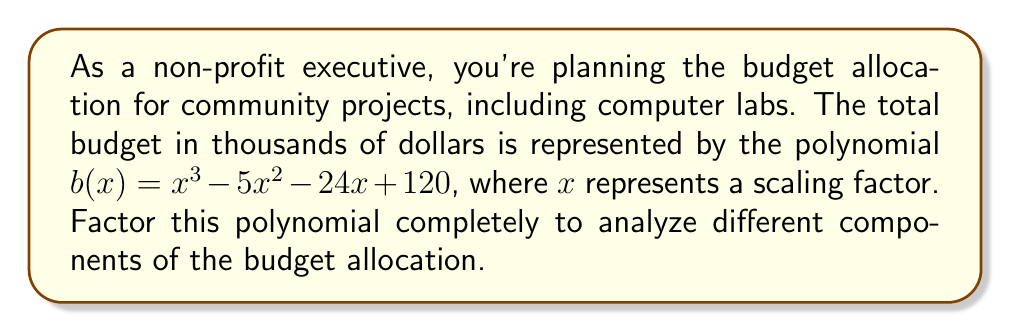Provide a solution to this math problem. To factor this polynomial, we'll follow these steps:

1) First, let's check if there are any common factors. In this case, there are none.

2) Next, we'll try to find a factor using the rational root theorem. The possible rational roots are the factors of the constant term (120): ±1, ±2, ±3, ±4, ±5, ±6, ±8, ±10, ±12, ±15, ±20, ±24, ±30, ±40, ±60, ±120.

3) Testing these values, we find that $x = 8$ is a root. So $(x - 8)$ is a factor.

4) We can use polynomial long division to divide $b(x)$ by $(x - 8)$:

   $$x^3 - 5x^2 - 24x + 120 = (x - 8)(x^2 + 3x - 15)$$

5) Now we need to factor the quadratic $x^2 + 3x - 15$. We can do this by finding two numbers that multiply to give -15 and add to give 3. These numbers are 6 and -3.

6) Therefore, $x^2 + 3x - 15 = (x + 6)(x - 3)$

7) Combining all factors, we get:

   $$b(x) = (x - 8)(x + 6)(x - 3)$$

This factorization allows us to analyze the budget in terms of three scaling components, which could represent different aspects of the community projects.
Answer: $b(x) = (x - 8)(x + 6)(x - 3)$ 